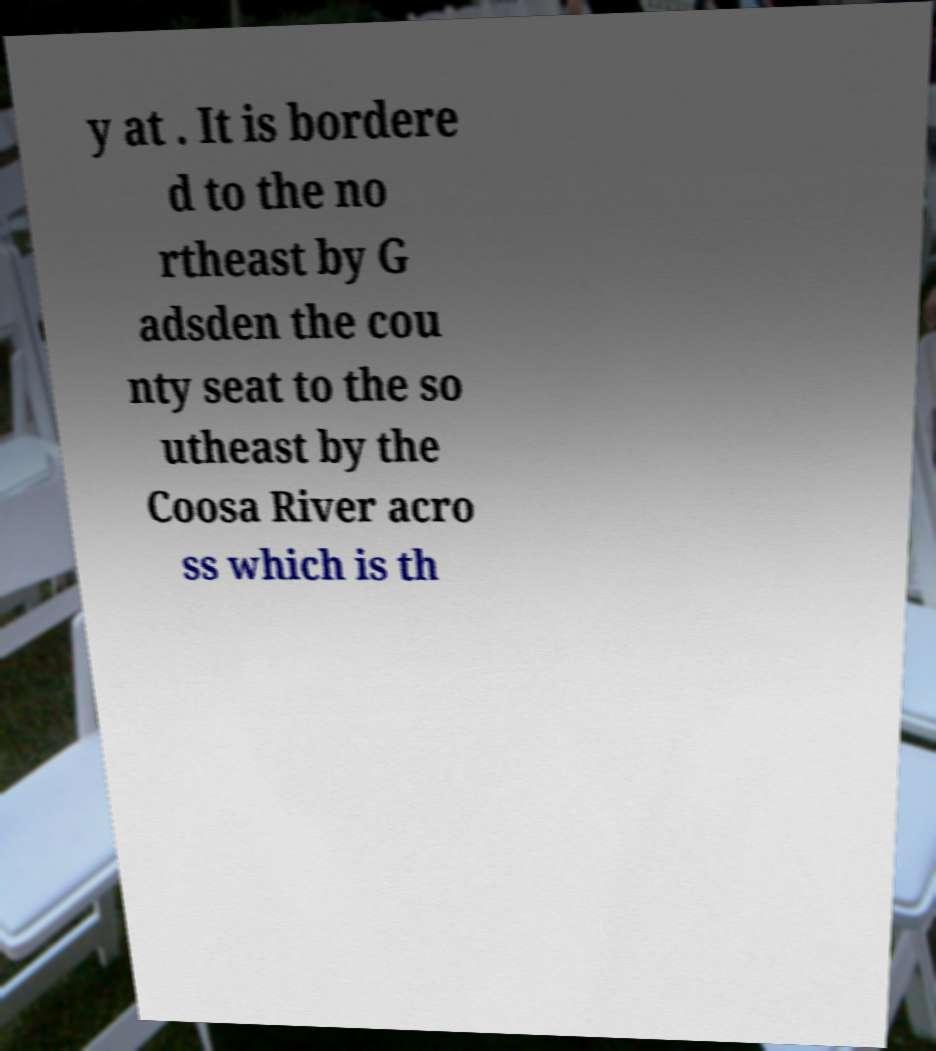Could you assist in decoding the text presented in this image and type it out clearly? y at . It is bordere d to the no rtheast by G adsden the cou nty seat to the so utheast by the Coosa River acro ss which is th 